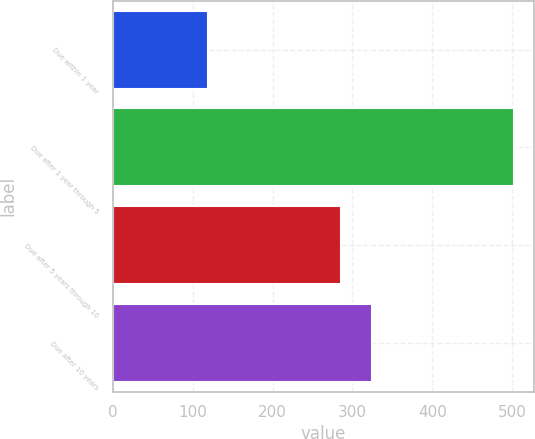Convert chart. <chart><loc_0><loc_0><loc_500><loc_500><bar_chart><fcel>Due within 1 year<fcel>Due after 1 year through 5<fcel>Due after 5 years through 10<fcel>Due after 10 years<nl><fcel>119.1<fcel>502<fcel>285.8<fcel>324.9<nl></chart> 